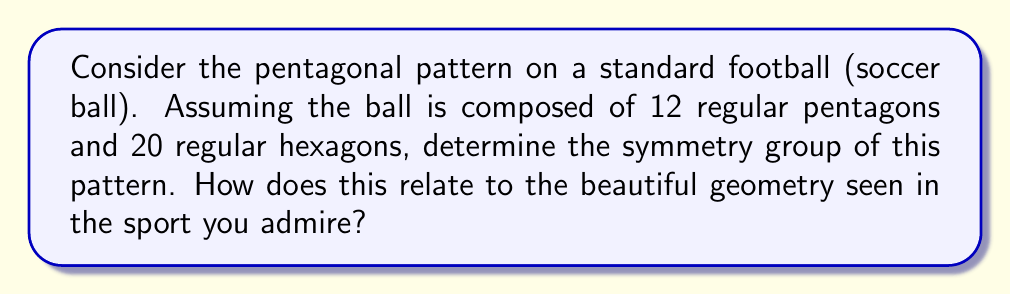Teach me how to tackle this problem. Let's approach this step-by-step:

1) First, we need to recognize that the pattern on a standard football forms a truncated icosahedron. This is a Archimedean solid with 60 vertices, 90 edges, and 32 faces (12 pentagons and 20 hexagons).

2) The symmetry group of this pattern is the same as the symmetry group of the icosahedron, which is the icosahedral group.

3) The icosahedral group, denoted as $A_5$, is an alternating group of order 60. It consists of all even permutations of 5 elements.

4) The order of this group can be calculated as follows:
   $$|A_5| = \frac{5!}{2} = 60$$

5) The group $A_5$ has several important properties:
   - It is the smallest non-abelian simple group.
   - It is isomorphic to the rotational symmetry group of the icosahedron and dodecahedron.

6) The symmetries of $A_5$ can be broken down as:
   - 15 rotations of order 2
   - 20 rotations of order 3
   - 24 rotations of order 5
   - The identity element

7) In the context of football, this symmetry group represents the ways the ball can be rotated while maintaining its appearance. This contributes to the ball's consistent behavior during play, which is crucial for the skill and precision admired in the sport.

8) The beauty of the sport is reflected in this mathematical elegance: just as players must work together in harmony, the pentagons and hexagons on the ball form a perfect symmetrical structure.
Answer: $A_5$, the alternating group of order 60 